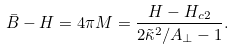Convert formula to latex. <formula><loc_0><loc_0><loc_500><loc_500>\bar { B } - H = 4 \pi M = \frac { H - H _ { c 2 } } { 2 \tilde { \kappa } ^ { 2 } / A _ { \perp } - 1 } .</formula> 